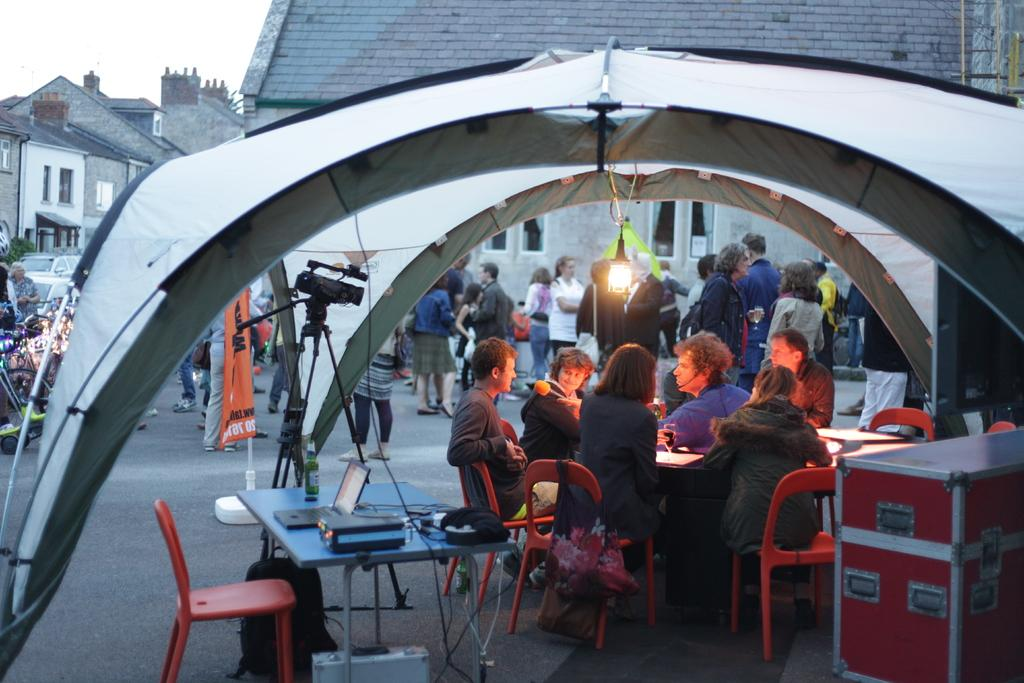What are the people in the image doing? The people in the image are sitting on chairs. Are there any other people visible in the image? Yes, there are people standing in the background of the image. What might the people sitting on chairs be using? They might be using the laptop on the table. What type of vegetable is being used as a stamp in the image? There is no vegetable being used as a stamp in the image. What type of work are the people in the image engaged in? The image does not provide enough information to determine the type of work the people are engaged in. 